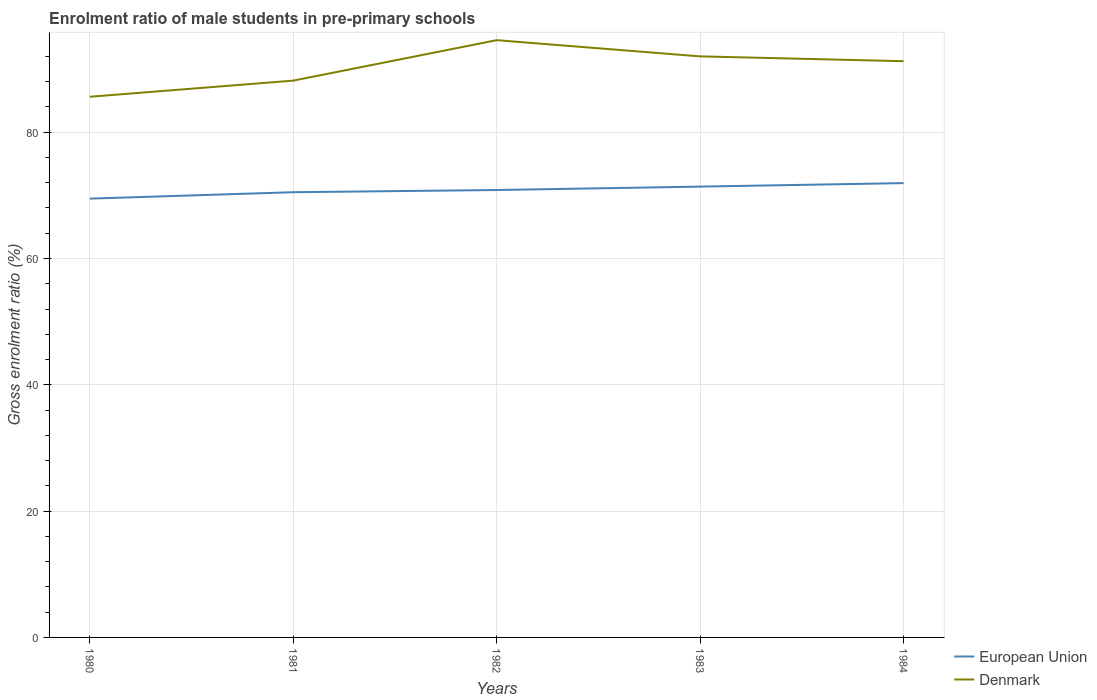How many different coloured lines are there?
Offer a terse response. 2. Across all years, what is the maximum enrolment ratio of male students in pre-primary schools in European Union?
Give a very brief answer. 69.48. What is the total enrolment ratio of male students in pre-primary schools in Denmark in the graph?
Keep it short and to the point. -8.96. What is the difference between the highest and the second highest enrolment ratio of male students in pre-primary schools in Denmark?
Offer a terse response. 8.96. Is the enrolment ratio of male students in pre-primary schools in European Union strictly greater than the enrolment ratio of male students in pre-primary schools in Denmark over the years?
Your answer should be compact. Yes. How many lines are there?
Make the answer very short. 2. How many years are there in the graph?
Provide a succinct answer. 5. What is the difference between two consecutive major ticks on the Y-axis?
Your response must be concise. 20. Are the values on the major ticks of Y-axis written in scientific E-notation?
Ensure brevity in your answer.  No. Does the graph contain grids?
Give a very brief answer. Yes. How are the legend labels stacked?
Your answer should be compact. Vertical. What is the title of the graph?
Offer a very short reply. Enrolment ratio of male students in pre-primary schools. Does "Bangladesh" appear as one of the legend labels in the graph?
Keep it short and to the point. No. What is the label or title of the X-axis?
Make the answer very short. Years. What is the Gross enrolment ratio (%) in European Union in 1980?
Ensure brevity in your answer.  69.48. What is the Gross enrolment ratio (%) in Denmark in 1980?
Your response must be concise. 85.61. What is the Gross enrolment ratio (%) in European Union in 1981?
Offer a very short reply. 70.5. What is the Gross enrolment ratio (%) in Denmark in 1981?
Provide a short and direct response. 88.17. What is the Gross enrolment ratio (%) of European Union in 1982?
Offer a very short reply. 70.85. What is the Gross enrolment ratio (%) in Denmark in 1982?
Your response must be concise. 94.57. What is the Gross enrolment ratio (%) in European Union in 1983?
Offer a terse response. 71.39. What is the Gross enrolment ratio (%) in Denmark in 1983?
Provide a succinct answer. 92.01. What is the Gross enrolment ratio (%) in European Union in 1984?
Make the answer very short. 71.94. What is the Gross enrolment ratio (%) in Denmark in 1984?
Offer a terse response. 91.25. Across all years, what is the maximum Gross enrolment ratio (%) in European Union?
Offer a terse response. 71.94. Across all years, what is the maximum Gross enrolment ratio (%) of Denmark?
Provide a succinct answer. 94.57. Across all years, what is the minimum Gross enrolment ratio (%) of European Union?
Provide a succinct answer. 69.48. Across all years, what is the minimum Gross enrolment ratio (%) of Denmark?
Offer a very short reply. 85.61. What is the total Gross enrolment ratio (%) in European Union in the graph?
Offer a very short reply. 354.16. What is the total Gross enrolment ratio (%) in Denmark in the graph?
Offer a very short reply. 451.61. What is the difference between the Gross enrolment ratio (%) in European Union in 1980 and that in 1981?
Offer a very short reply. -1.01. What is the difference between the Gross enrolment ratio (%) of Denmark in 1980 and that in 1981?
Provide a succinct answer. -2.56. What is the difference between the Gross enrolment ratio (%) of European Union in 1980 and that in 1982?
Give a very brief answer. -1.36. What is the difference between the Gross enrolment ratio (%) in Denmark in 1980 and that in 1982?
Give a very brief answer. -8.96. What is the difference between the Gross enrolment ratio (%) of European Union in 1980 and that in 1983?
Offer a terse response. -1.9. What is the difference between the Gross enrolment ratio (%) of Denmark in 1980 and that in 1983?
Your answer should be very brief. -6.39. What is the difference between the Gross enrolment ratio (%) in European Union in 1980 and that in 1984?
Your answer should be compact. -2.46. What is the difference between the Gross enrolment ratio (%) of Denmark in 1980 and that in 1984?
Keep it short and to the point. -5.63. What is the difference between the Gross enrolment ratio (%) of European Union in 1981 and that in 1982?
Provide a short and direct response. -0.35. What is the difference between the Gross enrolment ratio (%) in Denmark in 1981 and that in 1982?
Your answer should be very brief. -6.4. What is the difference between the Gross enrolment ratio (%) in European Union in 1981 and that in 1983?
Make the answer very short. -0.89. What is the difference between the Gross enrolment ratio (%) in Denmark in 1981 and that in 1983?
Ensure brevity in your answer.  -3.84. What is the difference between the Gross enrolment ratio (%) of European Union in 1981 and that in 1984?
Offer a terse response. -1.44. What is the difference between the Gross enrolment ratio (%) in Denmark in 1981 and that in 1984?
Offer a terse response. -3.08. What is the difference between the Gross enrolment ratio (%) in European Union in 1982 and that in 1983?
Make the answer very short. -0.54. What is the difference between the Gross enrolment ratio (%) of Denmark in 1982 and that in 1983?
Make the answer very short. 2.57. What is the difference between the Gross enrolment ratio (%) of European Union in 1982 and that in 1984?
Offer a very short reply. -1.09. What is the difference between the Gross enrolment ratio (%) of Denmark in 1982 and that in 1984?
Provide a succinct answer. 3.33. What is the difference between the Gross enrolment ratio (%) in European Union in 1983 and that in 1984?
Make the answer very short. -0.55. What is the difference between the Gross enrolment ratio (%) of Denmark in 1983 and that in 1984?
Ensure brevity in your answer.  0.76. What is the difference between the Gross enrolment ratio (%) of European Union in 1980 and the Gross enrolment ratio (%) of Denmark in 1981?
Ensure brevity in your answer.  -18.69. What is the difference between the Gross enrolment ratio (%) of European Union in 1980 and the Gross enrolment ratio (%) of Denmark in 1982?
Make the answer very short. -25.09. What is the difference between the Gross enrolment ratio (%) of European Union in 1980 and the Gross enrolment ratio (%) of Denmark in 1983?
Offer a terse response. -22.52. What is the difference between the Gross enrolment ratio (%) in European Union in 1980 and the Gross enrolment ratio (%) in Denmark in 1984?
Keep it short and to the point. -21.76. What is the difference between the Gross enrolment ratio (%) of European Union in 1981 and the Gross enrolment ratio (%) of Denmark in 1982?
Make the answer very short. -24.08. What is the difference between the Gross enrolment ratio (%) of European Union in 1981 and the Gross enrolment ratio (%) of Denmark in 1983?
Ensure brevity in your answer.  -21.51. What is the difference between the Gross enrolment ratio (%) of European Union in 1981 and the Gross enrolment ratio (%) of Denmark in 1984?
Ensure brevity in your answer.  -20.75. What is the difference between the Gross enrolment ratio (%) in European Union in 1982 and the Gross enrolment ratio (%) in Denmark in 1983?
Keep it short and to the point. -21.16. What is the difference between the Gross enrolment ratio (%) of European Union in 1982 and the Gross enrolment ratio (%) of Denmark in 1984?
Your answer should be compact. -20.4. What is the difference between the Gross enrolment ratio (%) in European Union in 1983 and the Gross enrolment ratio (%) in Denmark in 1984?
Offer a very short reply. -19.86. What is the average Gross enrolment ratio (%) in European Union per year?
Make the answer very short. 70.83. What is the average Gross enrolment ratio (%) of Denmark per year?
Offer a terse response. 90.32. In the year 1980, what is the difference between the Gross enrolment ratio (%) of European Union and Gross enrolment ratio (%) of Denmark?
Your answer should be very brief. -16.13. In the year 1981, what is the difference between the Gross enrolment ratio (%) in European Union and Gross enrolment ratio (%) in Denmark?
Your response must be concise. -17.67. In the year 1982, what is the difference between the Gross enrolment ratio (%) of European Union and Gross enrolment ratio (%) of Denmark?
Your answer should be compact. -23.73. In the year 1983, what is the difference between the Gross enrolment ratio (%) of European Union and Gross enrolment ratio (%) of Denmark?
Offer a very short reply. -20.62. In the year 1984, what is the difference between the Gross enrolment ratio (%) in European Union and Gross enrolment ratio (%) in Denmark?
Keep it short and to the point. -19.3. What is the ratio of the Gross enrolment ratio (%) of European Union in 1980 to that in 1981?
Provide a short and direct response. 0.99. What is the ratio of the Gross enrolment ratio (%) in Denmark in 1980 to that in 1981?
Your answer should be compact. 0.97. What is the ratio of the Gross enrolment ratio (%) in European Union in 1980 to that in 1982?
Give a very brief answer. 0.98. What is the ratio of the Gross enrolment ratio (%) of Denmark in 1980 to that in 1982?
Your answer should be compact. 0.91. What is the ratio of the Gross enrolment ratio (%) of European Union in 1980 to that in 1983?
Your response must be concise. 0.97. What is the ratio of the Gross enrolment ratio (%) in Denmark in 1980 to that in 1983?
Provide a succinct answer. 0.93. What is the ratio of the Gross enrolment ratio (%) in European Union in 1980 to that in 1984?
Give a very brief answer. 0.97. What is the ratio of the Gross enrolment ratio (%) of Denmark in 1980 to that in 1984?
Provide a short and direct response. 0.94. What is the ratio of the Gross enrolment ratio (%) in European Union in 1981 to that in 1982?
Provide a succinct answer. 1. What is the ratio of the Gross enrolment ratio (%) in Denmark in 1981 to that in 1982?
Provide a short and direct response. 0.93. What is the ratio of the Gross enrolment ratio (%) in European Union in 1981 to that in 1983?
Your answer should be compact. 0.99. What is the ratio of the Gross enrolment ratio (%) in European Union in 1981 to that in 1984?
Give a very brief answer. 0.98. What is the ratio of the Gross enrolment ratio (%) in Denmark in 1981 to that in 1984?
Keep it short and to the point. 0.97. What is the ratio of the Gross enrolment ratio (%) in European Union in 1982 to that in 1983?
Give a very brief answer. 0.99. What is the ratio of the Gross enrolment ratio (%) of Denmark in 1982 to that in 1983?
Provide a succinct answer. 1.03. What is the ratio of the Gross enrolment ratio (%) of Denmark in 1982 to that in 1984?
Your response must be concise. 1.04. What is the ratio of the Gross enrolment ratio (%) of European Union in 1983 to that in 1984?
Make the answer very short. 0.99. What is the ratio of the Gross enrolment ratio (%) of Denmark in 1983 to that in 1984?
Your answer should be compact. 1.01. What is the difference between the highest and the second highest Gross enrolment ratio (%) of European Union?
Your answer should be compact. 0.55. What is the difference between the highest and the second highest Gross enrolment ratio (%) of Denmark?
Provide a short and direct response. 2.57. What is the difference between the highest and the lowest Gross enrolment ratio (%) of European Union?
Your answer should be compact. 2.46. What is the difference between the highest and the lowest Gross enrolment ratio (%) of Denmark?
Ensure brevity in your answer.  8.96. 